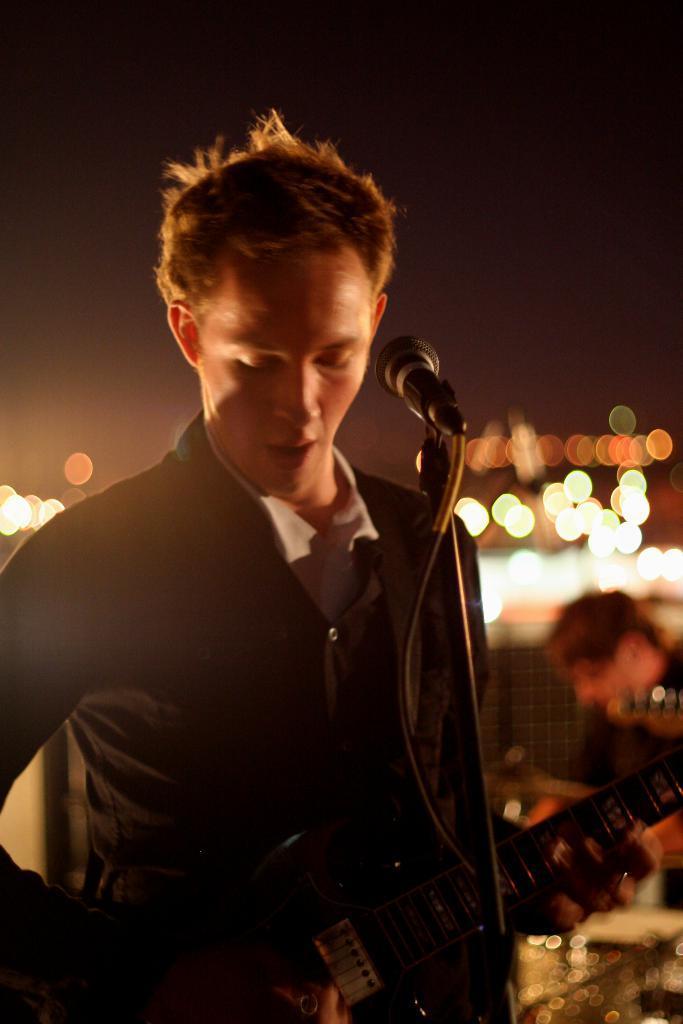How would you summarize this image in a sentence or two? In this picture we can see a man who is playing guitar. This is mike and there are lights. 